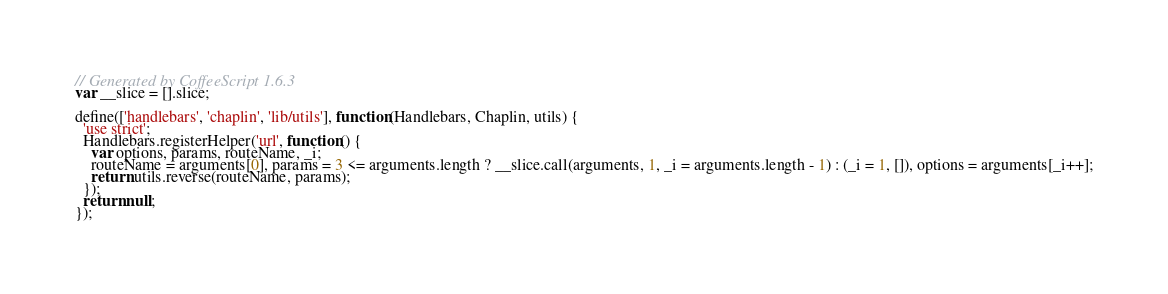Convert code to text. <code><loc_0><loc_0><loc_500><loc_500><_JavaScript_>// Generated by CoffeeScript 1.6.3
var __slice = [].slice;

define(['handlebars', 'chaplin', 'lib/utils'], function(Handlebars, Chaplin, utils) {
  'use strict';
  Handlebars.registerHelper('url', function() {
    var options, params, routeName, _i;
    routeName = arguments[0], params = 3 <= arguments.length ? __slice.call(arguments, 1, _i = arguments.length - 1) : (_i = 1, []), options = arguments[_i++];
    return utils.reverse(routeName, params);
  });
  return null;
});
</code> 